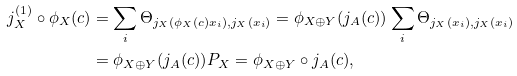Convert formula to latex. <formula><loc_0><loc_0><loc_500><loc_500>j _ { X } ^ { ( 1 ) } \circ \phi _ { X } ( c ) & = \sum _ { i } \Theta _ { j _ { X } ( \phi _ { X } ( c ) x _ { i } ) , j _ { X } ( x _ { i } ) } = \phi _ { X \oplus Y } ( j _ { A } ( c ) ) \sum _ { i } \Theta _ { j _ { X } ( x _ { i } ) , j _ { X } ( x _ { i } ) } \\ & = \phi _ { X \oplus Y } ( j _ { A } ( c ) ) P _ { X } = \phi _ { X \oplus Y } \circ j _ { A } ( c ) ,</formula> 